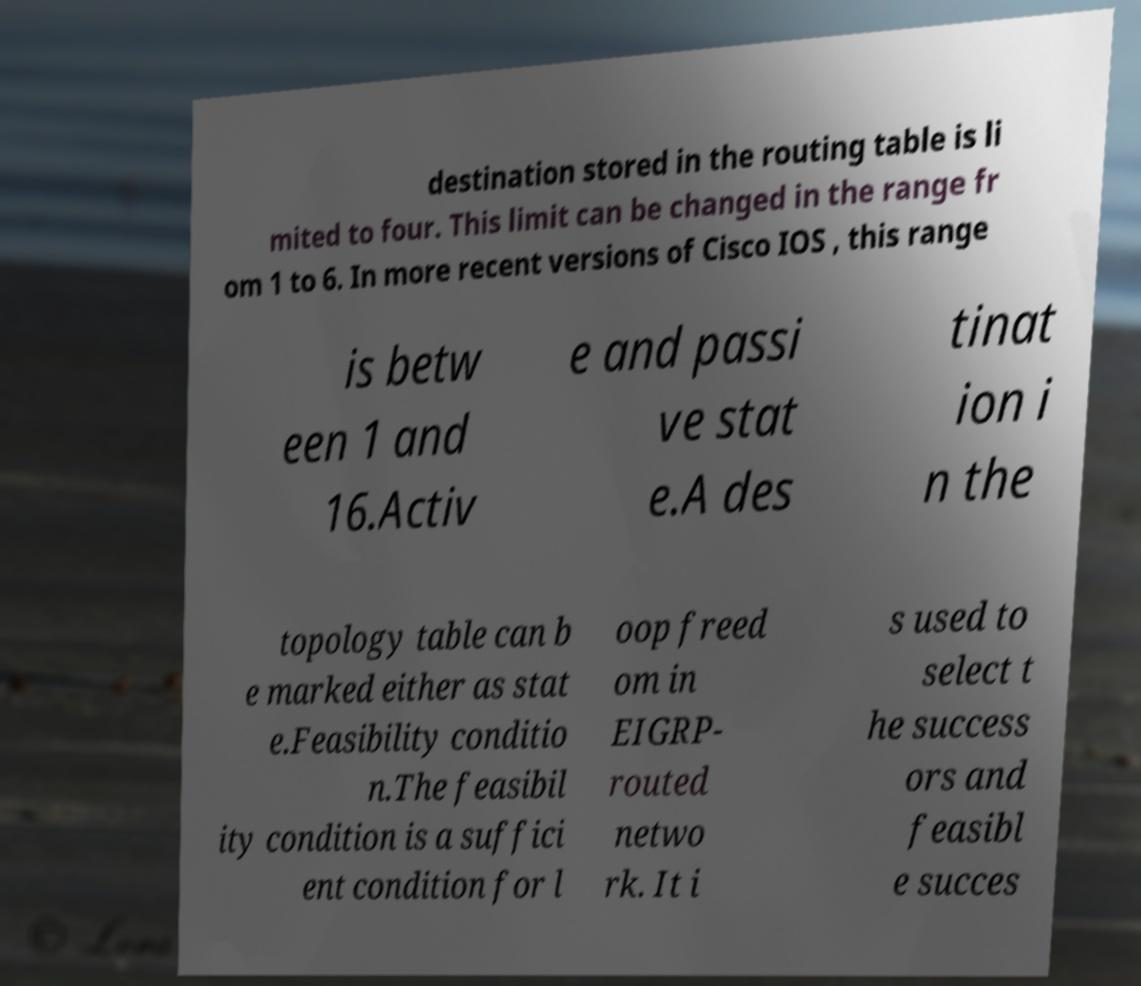Could you extract and type out the text from this image? destination stored in the routing table is li mited to four. This limit can be changed in the range fr om 1 to 6. In more recent versions of Cisco IOS , this range is betw een 1 and 16.Activ e and passi ve stat e.A des tinat ion i n the topology table can b e marked either as stat e.Feasibility conditio n.The feasibil ity condition is a suffici ent condition for l oop freed om in EIGRP- routed netwo rk. It i s used to select t he success ors and feasibl e succes 